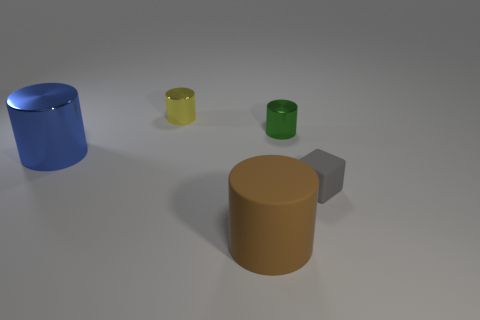What is the small yellow thing that is behind the metallic object on the right side of the cylinder in front of the big blue metallic cylinder made of?
Give a very brief answer. Metal. Is the blue cylinder the same size as the yellow shiny thing?
Ensure brevity in your answer.  No. What material is the green thing?
Offer a terse response. Metal. Does the shiny object right of the tiny yellow shiny cylinder have the same shape as the small gray object?
Give a very brief answer. No. What number of objects are either gray matte cubes or large brown cylinders?
Provide a succinct answer. 2. Do the blue cylinder in front of the small green metallic object and the brown object have the same material?
Provide a short and direct response. No. What is the size of the yellow metallic object?
Your answer should be compact. Small. How many balls are either tiny cyan matte things or small matte things?
Give a very brief answer. 0. Are there an equal number of gray matte objects in front of the big rubber cylinder and blue objects to the right of the gray thing?
Offer a very short reply. Yes. There is another yellow thing that is the same shape as the large matte thing; what is its size?
Offer a very short reply. Small. 